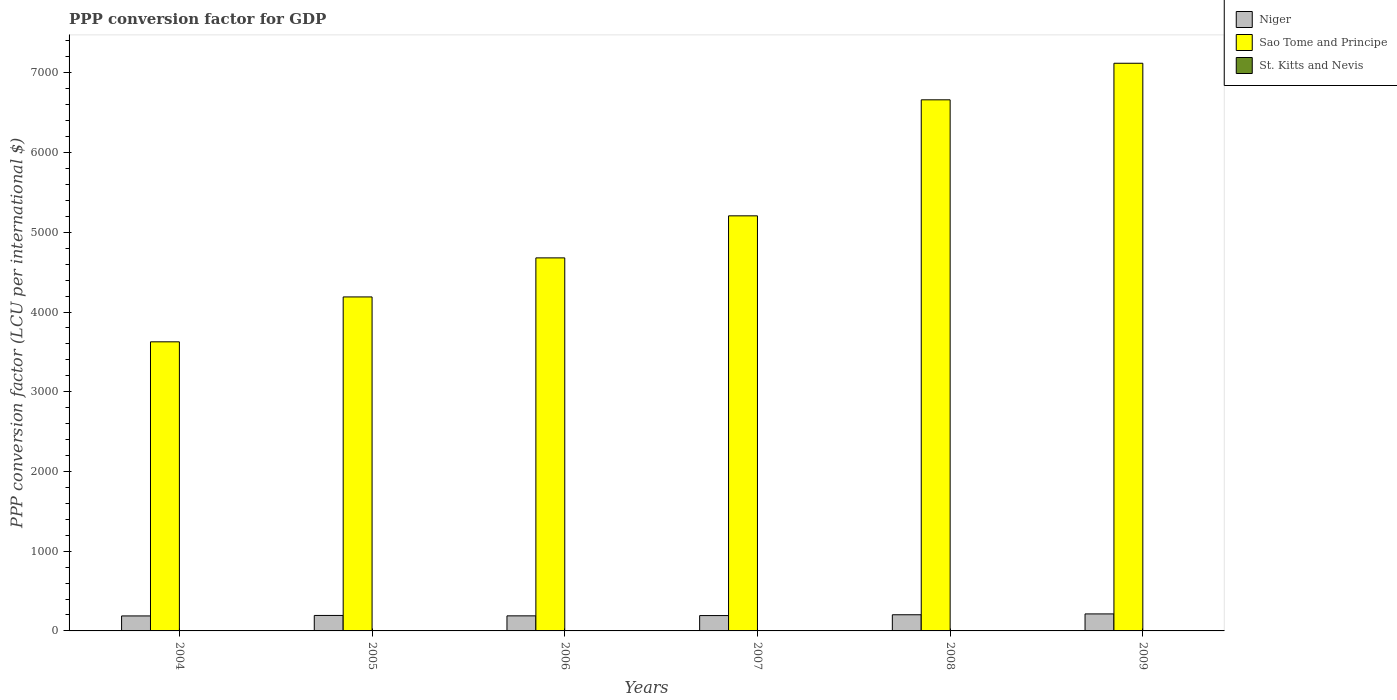How many different coloured bars are there?
Provide a short and direct response. 3. How many groups of bars are there?
Offer a very short reply. 6. What is the label of the 2nd group of bars from the left?
Give a very brief answer. 2005. What is the PPP conversion factor for GDP in Niger in 2006?
Offer a very short reply. 189.01. Across all years, what is the maximum PPP conversion factor for GDP in Sao Tome and Principe?
Offer a terse response. 7120.38. Across all years, what is the minimum PPP conversion factor for GDP in St. Kitts and Nevis?
Offer a terse response. 1.59. In which year was the PPP conversion factor for GDP in St. Kitts and Nevis maximum?
Make the answer very short. 2009. In which year was the PPP conversion factor for GDP in Niger minimum?
Offer a very short reply. 2004. What is the total PPP conversion factor for GDP in St. Kitts and Nevis in the graph?
Ensure brevity in your answer.  10.24. What is the difference between the PPP conversion factor for GDP in St. Kitts and Nevis in 2007 and that in 2009?
Offer a very short reply. -0.05. What is the difference between the PPP conversion factor for GDP in Niger in 2008 and the PPP conversion factor for GDP in Sao Tome and Principe in 2007?
Provide a succinct answer. -5003.81. What is the average PPP conversion factor for GDP in Sao Tome and Principe per year?
Offer a terse response. 5247.24. In the year 2006, what is the difference between the PPP conversion factor for GDP in Sao Tome and Principe and PPP conversion factor for GDP in St. Kitts and Nevis?
Your answer should be compact. 4677.36. What is the ratio of the PPP conversion factor for GDP in St. Kitts and Nevis in 2005 to that in 2009?
Provide a succinct answer. 0.89. Is the PPP conversion factor for GDP in St. Kitts and Nevis in 2007 less than that in 2009?
Ensure brevity in your answer.  Yes. What is the difference between the highest and the second highest PPP conversion factor for GDP in St. Kitts and Nevis?
Your response must be concise. 0.03. What is the difference between the highest and the lowest PPP conversion factor for GDP in Sao Tome and Principe?
Provide a short and direct response. 3494.04. In how many years, is the PPP conversion factor for GDP in Sao Tome and Principe greater than the average PPP conversion factor for GDP in Sao Tome and Principe taken over all years?
Provide a short and direct response. 2. Is the sum of the PPP conversion factor for GDP in Niger in 2005 and 2009 greater than the maximum PPP conversion factor for GDP in St. Kitts and Nevis across all years?
Your answer should be compact. Yes. What does the 3rd bar from the left in 2007 represents?
Your response must be concise. St. Kitts and Nevis. What does the 1st bar from the right in 2007 represents?
Your answer should be very brief. St. Kitts and Nevis. Is it the case that in every year, the sum of the PPP conversion factor for GDP in Sao Tome and Principe and PPP conversion factor for GDP in St. Kitts and Nevis is greater than the PPP conversion factor for GDP in Niger?
Your answer should be very brief. Yes. How many bars are there?
Your answer should be very brief. 18. Are the values on the major ticks of Y-axis written in scientific E-notation?
Ensure brevity in your answer.  No. Does the graph contain any zero values?
Your response must be concise. No. Does the graph contain grids?
Your answer should be compact. No. Where does the legend appear in the graph?
Keep it short and to the point. Top right. What is the title of the graph?
Provide a short and direct response. PPP conversion factor for GDP. Does "Jamaica" appear as one of the legend labels in the graph?
Provide a succinct answer. No. What is the label or title of the Y-axis?
Your answer should be compact. PPP conversion factor (LCU per international $). What is the PPP conversion factor (LCU per international $) in Niger in 2004?
Your answer should be compact. 188.03. What is the PPP conversion factor (LCU per international $) in Sao Tome and Principe in 2004?
Your response must be concise. 3626.34. What is the PPP conversion factor (LCU per international $) of St. Kitts and Nevis in 2004?
Offer a very short reply. 1.66. What is the PPP conversion factor (LCU per international $) in Niger in 2005?
Provide a short and direct response. 194.14. What is the PPP conversion factor (LCU per international $) of Sao Tome and Principe in 2005?
Your answer should be very brief. 4189.42. What is the PPP conversion factor (LCU per international $) of St. Kitts and Nevis in 2005?
Ensure brevity in your answer.  1.59. What is the PPP conversion factor (LCU per international $) in Niger in 2006?
Your answer should be compact. 189.01. What is the PPP conversion factor (LCU per international $) in Sao Tome and Principe in 2006?
Give a very brief answer. 4679.07. What is the PPP conversion factor (LCU per international $) in St. Kitts and Nevis in 2006?
Ensure brevity in your answer.  1.71. What is the PPP conversion factor (LCU per international $) in Niger in 2007?
Your response must be concise. 192.52. What is the PPP conversion factor (LCU per international $) in Sao Tome and Principe in 2007?
Provide a succinct answer. 5206.51. What is the PPP conversion factor (LCU per international $) of St. Kitts and Nevis in 2007?
Your answer should be very brief. 1.74. What is the PPP conversion factor (LCU per international $) in Niger in 2008?
Provide a short and direct response. 202.7. What is the PPP conversion factor (LCU per international $) in Sao Tome and Principe in 2008?
Your answer should be compact. 6661.74. What is the PPP conversion factor (LCU per international $) in St. Kitts and Nevis in 2008?
Provide a succinct answer. 1.76. What is the PPP conversion factor (LCU per international $) of Niger in 2009?
Make the answer very short. 213.4. What is the PPP conversion factor (LCU per international $) of Sao Tome and Principe in 2009?
Offer a terse response. 7120.38. What is the PPP conversion factor (LCU per international $) of St. Kitts and Nevis in 2009?
Your response must be concise. 1.78. Across all years, what is the maximum PPP conversion factor (LCU per international $) of Niger?
Your answer should be very brief. 213.4. Across all years, what is the maximum PPP conversion factor (LCU per international $) of Sao Tome and Principe?
Offer a very short reply. 7120.38. Across all years, what is the maximum PPP conversion factor (LCU per international $) of St. Kitts and Nevis?
Your answer should be compact. 1.78. Across all years, what is the minimum PPP conversion factor (LCU per international $) of Niger?
Offer a terse response. 188.03. Across all years, what is the minimum PPP conversion factor (LCU per international $) of Sao Tome and Principe?
Provide a succinct answer. 3626.34. Across all years, what is the minimum PPP conversion factor (LCU per international $) in St. Kitts and Nevis?
Your response must be concise. 1.59. What is the total PPP conversion factor (LCU per international $) in Niger in the graph?
Provide a short and direct response. 1179.8. What is the total PPP conversion factor (LCU per international $) of Sao Tome and Principe in the graph?
Your answer should be compact. 3.15e+04. What is the total PPP conversion factor (LCU per international $) of St. Kitts and Nevis in the graph?
Your answer should be very brief. 10.24. What is the difference between the PPP conversion factor (LCU per international $) of Niger in 2004 and that in 2005?
Make the answer very short. -6.11. What is the difference between the PPP conversion factor (LCU per international $) of Sao Tome and Principe in 2004 and that in 2005?
Your answer should be compact. -563.08. What is the difference between the PPP conversion factor (LCU per international $) of St. Kitts and Nevis in 2004 and that in 2005?
Make the answer very short. 0.06. What is the difference between the PPP conversion factor (LCU per international $) of Niger in 2004 and that in 2006?
Make the answer very short. -0.97. What is the difference between the PPP conversion factor (LCU per international $) in Sao Tome and Principe in 2004 and that in 2006?
Offer a terse response. -1052.73. What is the difference between the PPP conversion factor (LCU per international $) in St. Kitts and Nevis in 2004 and that in 2006?
Your answer should be compact. -0.05. What is the difference between the PPP conversion factor (LCU per international $) of Niger in 2004 and that in 2007?
Your response must be concise. -4.48. What is the difference between the PPP conversion factor (LCU per international $) in Sao Tome and Principe in 2004 and that in 2007?
Your answer should be compact. -1580.17. What is the difference between the PPP conversion factor (LCU per international $) in St. Kitts and Nevis in 2004 and that in 2007?
Ensure brevity in your answer.  -0.08. What is the difference between the PPP conversion factor (LCU per international $) of Niger in 2004 and that in 2008?
Your answer should be very brief. -14.66. What is the difference between the PPP conversion factor (LCU per international $) of Sao Tome and Principe in 2004 and that in 2008?
Give a very brief answer. -3035.4. What is the difference between the PPP conversion factor (LCU per international $) of St. Kitts and Nevis in 2004 and that in 2008?
Give a very brief answer. -0.1. What is the difference between the PPP conversion factor (LCU per international $) in Niger in 2004 and that in 2009?
Ensure brevity in your answer.  -25.37. What is the difference between the PPP conversion factor (LCU per international $) of Sao Tome and Principe in 2004 and that in 2009?
Provide a succinct answer. -3494.04. What is the difference between the PPP conversion factor (LCU per international $) in St. Kitts and Nevis in 2004 and that in 2009?
Give a very brief answer. -0.13. What is the difference between the PPP conversion factor (LCU per international $) in Niger in 2005 and that in 2006?
Provide a succinct answer. 5.14. What is the difference between the PPP conversion factor (LCU per international $) of Sao Tome and Principe in 2005 and that in 2006?
Ensure brevity in your answer.  -489.65. What is the difference between the PPP conversion factor (LCU per international $) in St. Kitts and Nevis in 2005 and that in 2006?
Your response must be concise. -0.12. What is the difference between the PPP conversion factor (LCU per international $) in Niger in 2005 and that in 2007?
Make the answer very short. 1.62. What is the difference between the PPP conversion factor (LCU per international $) of Sao Tome and Principe in 2005 and that in 2007?
Offer a very short reply. -1017.09. What is the difference between the PPP conversion factor (LCU per international $) of St. Kitts and Nevis in 2005 and that in 2007?
Give a very brief answer. -0.15. What is the difference between the PPP conversion factor (LCU per international $) in Niger in 2005 and that in 2008?
Your answer should be compact. -8.56. What is the difference between the PPP conversion factor (LCU per international $) in Sao Tome and Principe in 2005 and that in 2008?
Keep it short and to the point. -2472.32. What is the difference between the PPP conversion factor (LCU per international $) of St. Kitts and Nevis in 2005 and that in 2008?
Your answer should be compact. -0.17. What is the difference between the PPP conversion factor (LCU per international $) in Niger in 2005 and that in 2009?
Ensure brevity in your answer.  -19.26. What is the difference between the PPP conversion factor (LCU per international $) of Sao Tome and Principe in 2005 and that in 2009?
Keep it short and to the point. -2930.96. What is the difference between the PPP conversion factor (LCU per international $) of St. Kitts and Nevis in 2005 and that in 2009?
Keep it short and to the point. -0.19. What is the difference between the PPP conversion factor (LCU per international $) in Niger in 2006 and that in 2007?
Your answer should be compact. -3.51. What is the difference between the PPP conversion factor (LCU per international $) in Sao Tome and Principe in 2006 and that in 2007?
Offer a terse response. -527.44. What is the difference between the PPP conversion factor (LCU per international $) of St. Kitts and Nevis in 2006 and that in 2007?
Ensure brevity in your answer.  -0.03. What is the difference between the PPP conversion factor (LCU per international $) of Niger in 2006 and that in 2008?
Offer a very short reply. -13.69. What is the difference between the PPP conversion factor (LCU per international $) of Sao Tome and Principe in 2006 and that in 2008?
Make the answer very short. -1982.67. What is the difference between the PPP conversion factor (LCU per international $) of St. Kitts and Nevis in 2006 and that in 2008?
Offer a terse response. -0.05. What is the difference between the PPP conversion factor (LCU per international $) of Niger in 2006 and that in 2009?
Provide a succinct answer. -24.4. What is the difference between the PPP conversion factor (LCU per international $) of Sao Tome and Principe in 2006 and that in 2009?
Provide a succinct answer. -2441.31. What is the difference between the PPP conversion factor (LCU per international $) in St. Kitts and Nevis in 2006 and that in 2009?
Make the answer very short. -0.08. What is the difference between the PPP conversion factor (LCU per international $) of Niger in 2007 and that in 2008?
Provide a succinct answer. -10.18. What is the difference between the PPP conversion factor (LCU per international $) of Sao Tome and Principe in 2007 and that in 2008?
Your answer should be compact. -1455.23. What is the difference between the PPP conversion factor (LCU per international $) of St. Kitts and Nevis in 2007 and that in 2008?
Make the answer very short. -0.02. What is the difference between the PPP conversion factor (LCU per international $) of Niger in 2007 and that in 2009?
Your answer should be very brief. -20.88. What is the difference between the PPP conversion factor (LCU per international $) in Sao Tome and Principe in 2007 and that in 2009?
Offer a terse response. -1913.87. What is the difference between the PPP conversion factor (LCU per international $) in St. Kitts and Nevis in 2007 and that in 2009?
Your answer should be very brief. -0.05. What is the difference between the PPP conversion factor (LCU per international $) of Niger in 2008 and that in 2009?
Offer a very short reply. -10.7. What is the difference between the PPP conversion factor (LCU per international $) of Sao Tome and Principe in 2008 and that in 2009?
Provide a succinct answer. -458.64. What is the difference between the PPP conversion factor (LCU per international $) in St. Kitts and Nevis in 2008 and that in 2009?
Your answer should be very brief. -0.03. What is the difference between the PPP conversion factor (LCU per international $) in Niger in 2004 and the PPP conversion factor (LCU per international $) in Sao Tome and Principe in 2005?
Your answer should be compact. -4001.38. What is the difference between the PPP conversion factor (LCU per international $) in Niger in 2004 and the PPP conversion factor (LCU per international $) in St. Kitts and Nevis in 2005?
Offer a terse response. 186.44. What is the difference between the PPP conversion factor (LCU per international $) of Sao Tome and Principe in 2004 and the PPP conversion factor (LCU per international $) of St. Kitts and Nevis in 2005?
Offer a very short reply. 3624.75. What is the difference between the PPP conversion factor (LCU per international $) of Niger in 2004 and the PPP conversion factor (LCU per international $) of Sao Tome and Principe in 2006?
Make the answer very short. -4491.03. What is the difference between the PPP conversion factor (LCU per international $) in Niger in 2004 and the PPP conversion factor (LCU per international $) in St. Kitts and Nevis in 2006?
Provide a succinct answer. 186.33. What is the difference between the PPP conversion factor (LCU per international $) of Sao Tome and Principe in 2004 and the PPP conversion factor (LCU per international $) of St. Kitts and Nevis in 2006?
Keep it short and to the point. 3624.63. What is the difference between the PPP conversion factor (LCU per international $) of Niger in 2004 and the PPP conversion factor (LCU per international $) of Sao Tome and Principe in 2007?
Your response must be concise. -5018.48. What is the difference between the PPP conversion factor (LCU per international $) of Niger in 2004 and the PPP conversion factor (LCU per international $) of St. Kitts and Nevis in 2007?
Offer a terse response. 186.3. What is the difference between the PPP conversion factor (LCU per international $) of Sao Tome and Principe in 2004 and the PPP conversion factor (LCU per international $) of St. Kitts and Nevis in 2007?
Your response must be concise. 3624.6. What is the difference between the PPP conversion factor (LCU per international $) of Niger in 2004 and the PPP conversion factor (LCU per international $) of Sao Tome and Principe in 2008?
Give a very brief answer. -6473.7. What is the difference between the PPP conversion factor (LCU per international $) of Niger in 2004 and the PPP conversion factor (LCU per international $) of St. Kitts and Nevis in 2008?
Your answer should be compact. 186.28. What is the difference between the PPP conversion factor (LCU per international $) of Sao Tome and Principe in 2004 and the PPP conversion factor (LCU per international $) of St. Kitts and Nevis in 2008?
Provide a succinct answer. 3624.58. What is the difference between the PPP conversion factor (LCU per international $) in Niger in 2004 and the PPP conversion factor (LCU per international $) in Sao Tome and Principe in 2009?
Your answer should be very brief. -6932.34. What is the difference between the PPP conversion factor (LCU per international $) in Niger in 2004 and the PPP conversion factor (LCU per international $) in St. Kitts and Nevis in 2009?
Ensure brevity in your answer.  186.25. What is the difference between the PPP conversion factor (LCU per international $) in Sao Tome and Principe in 2004 and the PPP conversion factor (LCU per international $) in St. Kitts and Nevis in 2009?
Your response must be concise. 3624.55. What is the difference between the PPP conversion factor (LCU per international $) in Niger in 2005 and the PPP conversion factor (LCU per international $) in Sao Tome and Principe in 2006?
Your answer should be very brief. -4484.92. What is the difference between the PPP conversion factor (LCU per international $) of Niger in 2005 and the PPP conversion factor (LCU per international $) of St. Kitts and Nevis in 2006?
Provide a succinct answer. 192.43. What is the difference between the PPP conversion factor (LCU per international $) in Sao Tome and Principe in 2005 and the PPP conversion factor (LCU per international $) in St. Kitts and Nevis in 2006?
Your answer should be very brief. 4187.71. What is the difference between the PPP conversion factor (LCU per international $) in Niger in 2005 and the PPP conversion factor (LCU per international $) in Sao Tome and Principe in 2007?
Offer a terse response. -5012.37. What is the difference between the PPP conversion factor (LCU per international $) in Niger in 2005 and the PPP conversion factor (LCU per international $) in St. Kitts and Nevis in 2007?
Offer a terse response. 192.4. What is the difference between the PPP conversion factor (LCU per international $) in Sao Tome and Principe in 2005 and the PPP conversion factor (LCU per international $) in St. Kitts and Nevis in 2007?
Ensure brevity in your answer.  4187.68. What is the difference between the PPP conversion factor (LCU per international $) in Niger in 2005 and the PPP conversion factor (LCU per international $) in Sao Tome and Principe in 2008?
Offer a very short reply. -6467.6. What is the difference between the PPP conversion factor (LCU per international $) of Niger in 2005 and the PPP conversion factor (LCU per international $) of St. Kitts and Nevis in 2008?
Give a very brief answer. 192.38. What is the difference between the PPP conversion factor (LCU per international $) in Sao Tome and Principe in 2005 and the PPP conversion factor (LCU per international $) in St. Kitts and Nevis in 2008?
Keep it short and to the point. 4187.66. What is the difference between the PPP conversion factor (LCU per international $) in Niger in 2005 and the PPP conversion factor (LCU per international $) in Sao Tome and Principe in 2009?
Your answer should be very brief. -6926.24. What is the difference between the PPP conversion factor (LCU per international $) of Niger in 2005 and the PPP conversion factor (LCU per international $) of St. Kitts and Nevis in 2009?
Make the answer very short. 192.36. What is the difference between the PPP conversion factor (LCU per international $) of Sao Tome and Principe in 2005 and the PPP conversion factor (LCU per international $) of St. Kitts and Nevis in 2009?
Give a very brief answer. 4187.63. What is the difference between the PPP conversion factor (LCU per international $) in Niger in 2006 and the PPP conversion factor (LCU per international $) in Sao Tome and Principe in 2007?
Your answer should be compact. -5017.51. What is the difference between the PPP conversion factor (LCU per international $) in Niger in 2006 and the PPP conversion factor (LCU per international $) in St. Kitts and Nevis in 2007?
Provide a succinct answer. 187.27. What is the difference between the PPP conversion factor (LCU per international $) in Sao Tome and Principe in 2006 and the PPP conversion factor (LCU per international $) in St. Kitts and Nevis in 2007?
Offer a very short reply. 4677.33. What is the difference between the PPP conversion factor (LCU per international $) of Niger in 2006 and the PPP conversion factor (LCU per international $) of Sao Tome and Principe in 2008?
Give a very brief answer. -6472.73. What is the difference between the PPP conversion factor (LCU per international $) in Niger in 2006 and the PPP conversion factor (LCU per international $) in St. Kitts and Nevis in 2008?
Offer a terse response. 187.25. What is the difference between the PPP conversion factor (LCU per international $) in Sao Tome and Principe in 2006 and the PPP conversion factor (LCU per international $) in St. Kitts and Nevis in 2008?
Provide a succinct answer. 4677.31. What is the difference between the PPP conversion factor (LCU per international $) of Niger in 2006 and the PPP conversion factor (LCU per international $) of Sao Tome and Principe in 2009?
Your answer should be very brief. -6931.37. What is the difference between the PPP conversion factor (LCU per international $) in Niger in 2006 and the PPP conversion factor (LCU per international $) in St. Kitts and Nevis in 2009?
Offer a terse response. 187.22. What is the difference between the PPP conversion factor (LCU per international $) in Sao Tome and Principe in 2006 and the PPP conversion factor (LCU per international $) in St. Kitts and Nevis in 2009?
Make the answer very short. 4677.28. What is the difference between the PPP conversion factor (LCU per international $) of Niger in 2007 and the PPP conversion factor (LCU per international $) of Sao Tome and Principe in 2008?
Give a very brief answer. -6469.22. What is the difference between the PPP conversion factor (LCU per international $) of Niger in 2007 and the PPP conversion factor (LCU per international $) of St. Kitts and Nevis in 2008?
Give a very brief answer. 190.76. What is the difference between the PPP conversion factor (LCU per international $) in Sao Tome and Principe in 2007 and the PPP conversion factor (LCU per international $) in St. Kitts and Nevis in 2008?
Provide a succinct answer. 5204.75. What is the difference between the PPP conversion factor (LCU per international $) of Niger in 2007 and the PPP conversion factor (LCU per international $) of Sao Tome and Principe in 2009?
Offer a very short reply. -6927.86. What is the difference between the PPP conversion factor (LCU per international $) in Niger in 2007 and the PPP conversion factor (LCU per international $) in St. Kitts and Nevis in 2009?
Give a very brief answer. 190.73. What is the difference between the PPP conversion factor (LCU per international $) in Sao Tome and Principe in 2007 and the PPP conversion factor (LCU per international $) in St. Kitts and Nevis in 2009?
Ensure brevity in your answer.  5204.73. What is the difference between the PPP conversion factor (LCU per international $) in Niger in 2008 and the PPP conversion factor (LCU per international $) in Sao Tome and Principe in 2009?
Provide a short and direct response. -6917.68. What is the difference between the PPP conversion factor (LCU per international $) in Niger in 2008 and the PPP conversion factor (LCU per international $) in St. Kitts and Nevis in 2009?
Offer a terse response. 200.91. What is the difference between the PPP conversion factor (LCU per international $) in Sao Tome and Principe in 2008 and the PPP conversion factor (LCU per international $) in St. Kitts and Nevis in 2009?
Your response must be concise. 6659.95. What is the average PPP conversion factor (LCU per international $) in Niger per year?
Ensure brevity in your answer.  196.63. What is the average PPP conversion factor (LCU per international $) in Sao Tome and Principe per year?
Provide a succinct answer. 5247.24. What is the average PPP conversion factor (LCU per international $) of St. Kitts and Nevis per year?
Provide a succinct answer. 1.71. In the year 2004, what is the difference between the PPP conversion factor (LCU per international $) in Niger and PPP conversion factor (LCU per international $) in Sao Tome and Principe?
Ensure brevity in your answer.  -3438.3. In the year 2004, what is the difference between the PPP conversion factor (LCU per international $) in Niger and PPP conversion factor (LCU per international $) in St. Kitts and Nevis?
Ensure brevity in your answer.  186.38. In the year 2004, what is the difference between the PPP conversion factor (LCU per international $) in Sao Tome and Principe and PPP conversion factor (LCU per international $) in St. Kitts and Nevis?
Your answer should be very brief. 3624.68. In the year 2005, what is the difference between the PPP conversion factor (LCU per international $) in Niger and PPP conversion factor (LCU per international $) in Sao Tome and Principe?
Your answer should be compact. -3995.28. In the year 2005, what is the difference between the PPP conversion factor (LCU per international $) in Niger and PPP conversion factor (LCU per international $) in St. Kitts and Nevis?
Provide a short and direct response. 192.55. In the year 2005, what is the difference between the PPP conversion factor (LCU per international $) in Sao Tome and Principe and PPP conversion factor (LCU per international $) in St. Kitts and Nevis?
Your response must be concise. 4187.83. In the year 2006, what is the difference between the PPP conversion factor (LCU per international $) in Niger and PPP conversion factor (LCU per international $) in Sao Tome and Principe?
Provide a succinct answer. -4490.06. In the year 2006, what is the difference between the PPP conversion factor (LCU per international $) of Niger and PPP conversion factor (LCU per international $) of St. Kitts and Nevis?
Your answer should be compact. 187.3. In the year 2006, what is the difference between the PPP conversion factor (LCU per international $) in Sao Tome and Principe and PPP conversion factor (LCU per international $) in St. Kitts and Nevis?
Offer a very short reply. 4677.36. In the year 2007, what is the difference between the PPP conversion factor (LCU per international $) in Niger and PPP conversion factor (LCU per international $) in Sao Tome and Principe?
Make the answer very short. -5013.99. In the year 2007, what is the difference between the PPP conversion factor (LCU per international $) of Niger and PPP conversion factor (LCU per international $) of St. Kitts and Nevis?
Give a very brief answer. 190.78. In the year 2007, what is the difference between the PPP conversion factor (LCU per international $) in Sao Tome and Principe and PPP conversion factor (LCU per international $) in St. Kitts and Nevis?
Offer a terse response. 5204.77. In the year 2008, what is the difference between the PPP conversion factor (LCU per international $) of Niger and PPP conversion factor (LCU per international $) of Sao Tome and Principe?
Ensure brevity in your answer.  -6459.04. In the year 2008, what is the difference between the PPP conversion factor (LCU per international $) of Niger and PPP conversion factor (LCU per international $) of St. Kitts and Nevis?
Provide a short and direct response. 200.94. In the year 2008, what is the difference between the PPP conversion factor (LCU per international $) in Sao Tome and Principe and PPP conversion factor (LCU per international $) in St. Kitts and Nevis?
Offer a very short reply. 6659.98. In the year 2009, what is the difference between the PPP conversion factor (LCU per international $) of Niger and PPP conversion factor (LCU per international $) of Sao Tome and Principe?
Your answer should be compact. -6906.98. In the year 2009, what is the difference between the PPP conversion factor (LCU per international $) in Niger and PPP conversion factor (LCU per international $) in St. Kitts and Nevis?
Your answer should be compact. 211.62. In the year 2009, what is the difference between the PPP conversion factor (LCU per international $) of Sao Tome and Principe and PPP conversion factor (LCU per international $) of St. Kitts and Nevis?
Give a very brief answer. 7118.59. What is the ratio of the PPP conversion factor (LCU per international $) in Niger in 2004 to that in 2005?
Offer a terse response. 0.97. What is the ratio of the PPP conversion factor (LCU per international $) in Sao Tome and Principe in 2004 to that in 2005?
Ensure brevity in your answer.  0.87. What is the ratio of the PPP conversion factor (LCU per international $) of St. Kitts and Nevis in 2004 to that in 2005?
Offer a very short reply. 1.04. What is the ratio of the PPP conversion factor (LCU per international $) of Niger in 2004 to that in 2006?
Ensure brevity in your answer.  0.99. What is the ratio of the PPP conversion factor (LCU per international $) of Sao Tome and Principe in 2004 to that in 2006?
Offer a terse response. 0.78. What is the ratio of the PPP conversion factor (LCU per international $) in St. Kitts and Nevis in 2004 to that in 2006?
Provide a succinct answer. 0.97. What is the ratio of the PPP conversion factor (LCU per international $) of Niger in 2004 to that in 2007?
Your answer should be very brief. 0.98. What is the ratio of the PPP conversion factor (LCU per international $) in Sao Tome and Principe in 2004 to that in 2007?
Offer a terse response. 0.7. What is the ratio of the PPP conversion factor (LCU per international $) of St. Kitts and Nevis in 2004 to that in 2007?
Offer a terse response. 0.95. What is the ratio of the PPP conversion factor (LCU per international $) of Niger in 2004 to that in 2008?
Provide a short and direct response. 0.93. What is the ratio of the PPP conversion factor (LCU per international $) of Sao Tome and Principe in 2004 to that in 2008?
Provide a short and direct response. 0.54. What is the ratio of the PPP conversion factor (LCU per international $) of St. Kitts and Nevis in 2004 to that in 2008?
Ensure brevity in your answer.  0.94. What is the ratio of the PPP conversion factor (LCU per international $) in Niger in 2004 to that in 2009?
Your answer should be very brief. 0.88. What is the ratio of the PPP conversion factor (LCU per international $) of Sao Tome and Principe in 2004 to that in 2009?
Your response must be concise. 0.51. What is the ratio of the PPP conversion factor (LCU per international $) in St. Kitts and Nevis in 2004 to that in 2009?
Offer a terse response. 0.93. What is the ratio of the PPP conversion factor (LCU per international $) in Niger in 2005 to that in 2006?
Provide a short and direct response. 1.03. What is the ratio of the PPP conversion factor (LCU per international $) in Sao Tome and Principe in 2005 to that in 2006?
Your response must be concise. 0.9. What is the ratio of the PPP conversion factor (LCU per international $) in St. Kitts and Nevis in 2005 to that in 2006?
Provide a short and direct response. 0.93. What is the ratio of the PPP conversion factor (LCU per international $) of Niger in 2005 to that in 2007?
Provide a succinct answer. 1.01. What is the ratio of the PPP conversion factor (LCU per international $) in Sao Tome and Principe in 2005 to that in 2007?
Offer a very short reply. 0.8. What is the ratio of the PPP conversion factor (LCU per international $) in St. Kitts and Nevis in 2005 to that in 2007?
Your answer should be compact. 0.91. What is the ratio of the PPP conversion factor (LCU per international $) in Niger in 2005 to that in 2008?
Keep it short and to the point. 0.96. What is the ratio of the PPP conversion factor (LCU per international $) of Sao Tome and Principe in 2005 to that in 2008?
Provide a succinct answer. 0.63. What is the ratio of the PPP conversion factor (LCU per international $) in St. Kitts and Nevis in 2005 to that in 2008?
Offer a very short reply. 0.9. What is the ratio of the PPP conversion factor (LCU per international $) of Niger in 2005 to that in 2009?
Make the answer very short. 0.91. What is the ratio of the PPP conversion factor (LCU per international $) in Sao Tome and Principe in 2005 to that in 2009?
Provide a succinct answer. 0.59. What is the ratio of the PPP conversion factor (LCU per international $) of St. Kitts and Nevis in 2005 to that in 2009?
Provide a short and direct response. 0.89. What is the ratio of the PPP conversion factor (LCU per international $) of Niger in 2006 to that in 2007?
Offer a terse response. 0.98. What is the ratio of the PPP conversion factor (LCU per international $) in Sao Tome and Principe in 2006 to that in 2007?
Keep it short and to the point. 0.9. What is the ratio of the PPP conversion factor (LCU per international $) in St. Kitts and Nevis in 2006 to that in 2007?
Your answer should be compact. 0.98. What is the ratio of the PPP conversion factor (LCU per international $) of Niger in 2006 to that in 2008?
Ensure brevity in your answer.  0.93. What is the ratio of the PPP conversion factor (LCU per international $) in Sao Tome and Principe in 2006 to that in 2008?
Your answer should be compact. 0.7. What is the ratio of the PPP conversion factor (LCU per international $) of St. Kitts and Nevis in 2006 to that in 2008?
Give a very brief answer. 0.97. What is the ratio of the PPP conversion factor (LCU per international $) in Niger in 2006 to that in 2009?
Ensure brevity in your answer.  0.89. What is the ratio of the PPP conversion factor (LCU per international $) of Sao Tome and Principe in 2006 to that in 2009?
Your response must be concise. 0.66. What is the ratio of the PPP conversion factor (LCU per international $) in St. Kitts and Nevis in 2006 to that in 2009?
Keep it short and to the point. 0.96. What is the ratio of the PPP conversion factor (LCU per international $) of Niger in 2007 to that in 2008?
Offer a terse response. 0.95. What is the ratio of the PPP conversion factor (LCU per international $) in Sao Tome and Principe in 2007 to that in 2008?
Your answer should be very brief. 0.78. What is the ratio of the PPP conversion factor (LCU per international $) of St. Kitts and Nevis in 2007 to that in 2008?
Give a very brief answer. 0.99. What is the ratio of the PPP conversion factor (LCU per international $) in Niger in 2007 to that in 2009?
Give a very brief answer. 0.9. What is the ratio of the PPP conversion factor (LCU per international $) of Sao Tome and Principe in 2007 to that in 2009?
Your answer should be very brief. 0.73. What is the ratio of the PPP conversion factor (LCU per international $) of St. Kitts and Nevis in 2007 to that in 2009?
Provide a succinct answer. 0.97. What is the ratio of the PPP conversion factor (LCU per international $) of Niger in 2008 to that in 2009?
Provide a short and direct response. 0.95. What is the ratio of the PPP conversion factor (LCU per international $) of Sao Tome and Principe in 2008 to that in 2009?
Offer a terse response. 0.94. What is the ratio of the PPP conversion factor (LCU per international $) in St. Kitts and Nevis in 2008 to that in 2009?
Provide a short and direct response. 0.99. What is the difference between the highest and the second highest PPP conversion factor (LCU per international $) in Niger?
Provide a short and direct response. 10.7. What is the difference between the highest and the second highest PPP conversion factor (LCU per international $) of Sao Tome and Principe?
Keep it short and to the point. 458.64. What is the difference between the highest and the second highest PPP conversion factor (LCU per international $) in St. Kitts and Nevis?
Make the answer very short. 0.03. What is the difference between the highest and the lowest PPP conversion factor (LCU per international $) of Niger?
Keep it short and to the point. 25.37. What is the difference between the highest and the lowest PPP conversion factor (LCU per international $) of Sao Tome and Principe?
Offer a very short reply. 3494.04. What is the difference between the highest and the lowest PPP conversion factor (LCU per international $) in St. Kitts and Nevis?
Offer a very short reply. 0.19. 